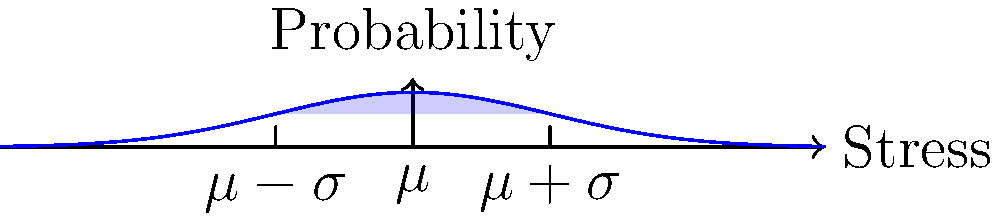In your latest novel, you're describing a character who's an engineer working on a beam subjected to random loads. The mechanical stress in the beam follows a normal distribution. If the mean stress is 200 MPa and the standard deviation is 30 MPa, what is the probability that the stress in a randomly chosen point of the beam will be between 170 MPa and 230 MPa? To solve this problem, we'll follow these steps:

1) Recognize that we're dealing with a normal distribution of stress.

2) The given information:
   - Mean stress ($\mu$) = 200 MPa
   - Standard deviation ($\sigma$) = 30 MPa
   - We want the probability between 170 MPa and 230 MPa

3) Calculate the z-scores for the lower and upper bounds:
   For 170 MPa: $z_1 = \frac{170 - 200}{30} = -1$
   For 230 MPa: $z_2 = \frac{230 - 200}{30} = 1$

4) The probability we're looking for is the area under the normal curve between these two z-scores.

5) For a standard normal distribution, the area between -1 and 1 standard deviations from the mean is approximately 0.6827 or 68.27%.

6) This value, 0.6827, represents the probability that a randomly chosen point on the beam will have a stress between 170 MPa and 230 MPa.

The graphic shows a standard normal distribution curve with the area between -1 and 1 standard deviations shaded, which corresponds to our calculated probability.
Answer: 0.6827 or 68.27% 